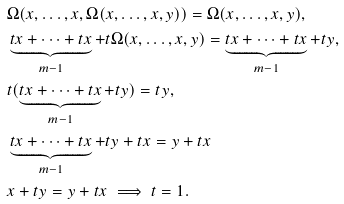Convert formula to latex. <formula><loc_0><loc_0><loc_500><loc_500>& \Omega ( x , \dots , x , \Omega ( x , \dots , x , y ) ) = \Omega ( x , \dots , x , y ) , \\ & \underbrace { t x + \dots + t x } _ { m - 1 } + t \Omega ( x , \dots , x , y ) = \underbrace { t x + \dots + t x } _ { m - 1 } + t y , \\ & t ( \underbrace { t x + \dots + t x } _ { m - 1 } + t y ) = t y , \\ & \underbrace { t x + \dots + t x } _ { m - 1 } + t y + t x = y + t x \\ & x + t y = y + t x \implies t = 1 .</formula> 